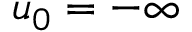Convert formula to latex. <formula><loc_0><loc_0><loc_500><loc_500>u _ { 0 } = - \infty</formula> 